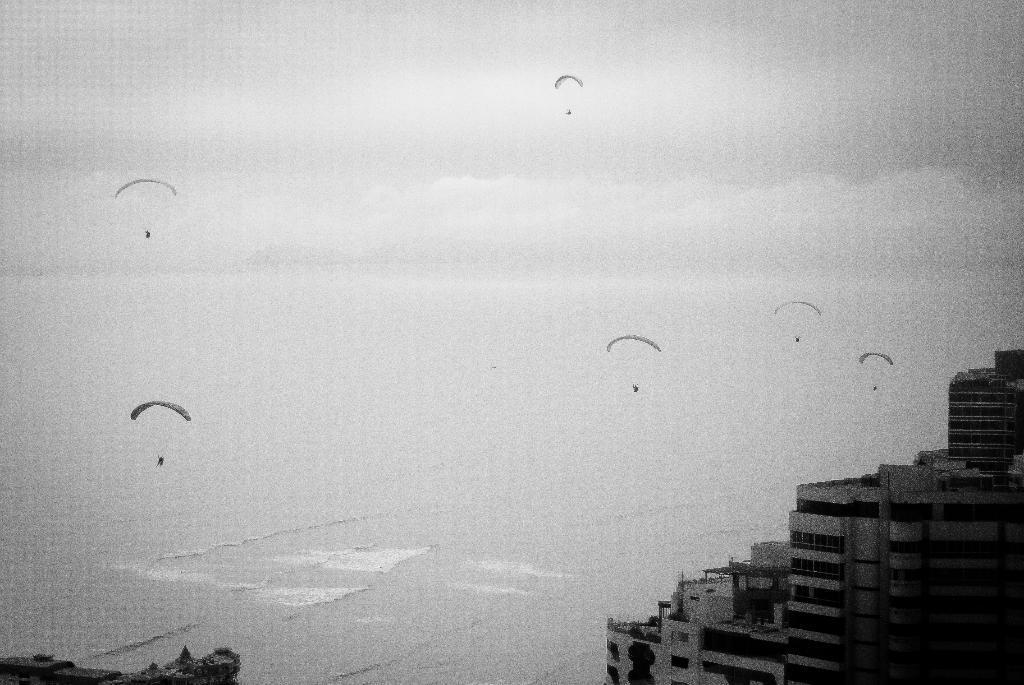How would you summarize this image in a sentence or two? This is a black and white image and here we can see buildings and at the top, there are parachutes. At the bottom, there is water. 